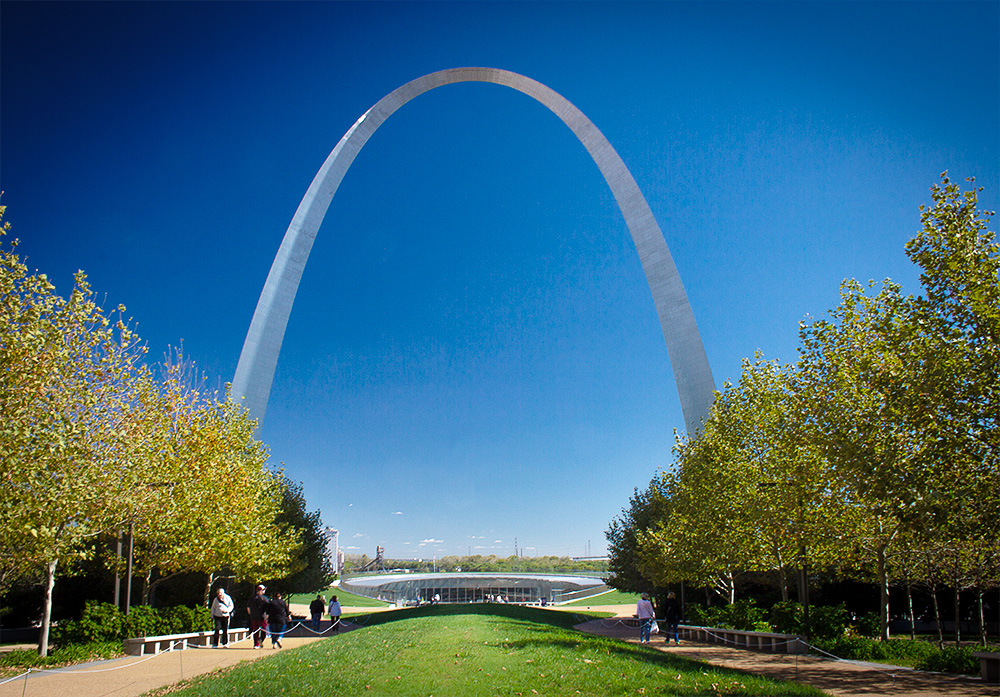How has the Gateway Arch impacted St. Louis culturally and economically? The Gateway Arch has had a profound impact on St. Louis, serving as a symbol of westward expansion and a major tourist attraction. It culturally represents the pioneering spirit of the early settlers, while economically, it has spurred development in the area, boosting local businesses and increasingly tourism-driven revenue. The Arch not only anchors the city's skyline but also its identity as a hub of historical significance. 